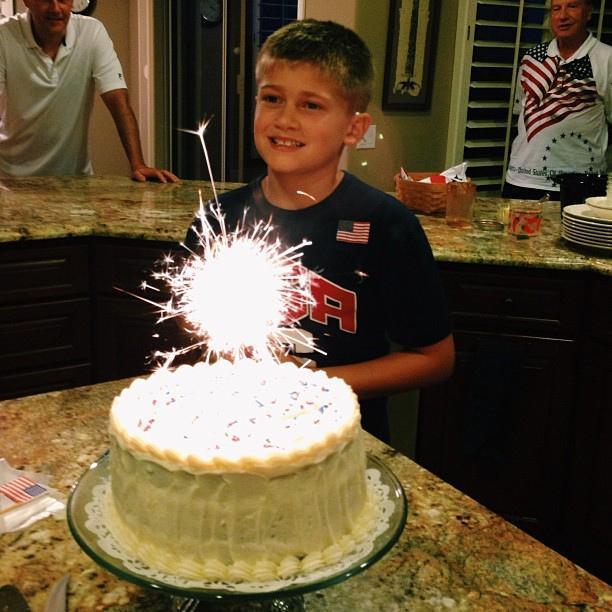How many people are there?
Give a very brief answer. 3. How many vases appear in the room?
Give a very brief answer. 0. 